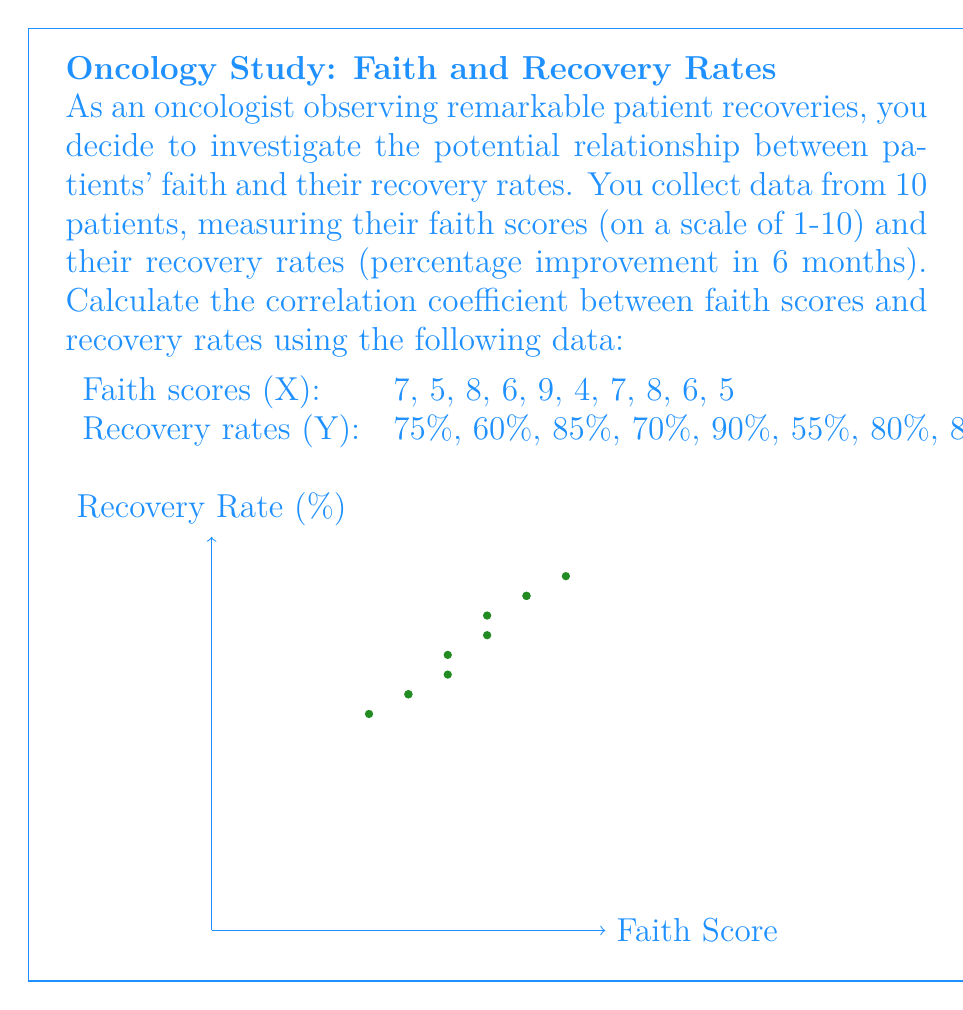Help me with this question. To calculate the correlation coefficient (r) between faith scores (X) and recovery rates (Y), we'll use the formula:

$$ r = \frac{n\sum xy - \sum x \sum y}{\sqrt{[n\sum x^2 - (\sum x)^2][n\sum y^2 - (\sum y)^2]}} $$

Step 1: Calculate the necessary sums:
$\sum x = 65$
$\sum y = 725$
$\sum xy = 4975$
$\sum x^2 = 449$
$\sum y^2 = 53875$
$n = 10$

Step 2: Substitute these values into the formula:

$$ r = \frac{10(4975) - (65)(725)}{\sqrt{[10(449) - 65^2][10(53875) - 725^2]}} $$

Step 3: Simplify:

$$ r = \frac{49750 - 47125}{\sqrt{(4490 - 4225)(538750 - 525625)}} $$

$$ r = \frac{2625}{\sqrt{265 * 13125}} $$

$$ r = \frac{2625}{\sqrt{3478125}} $$

$$ r = \frac{2625}{1865.51} $$

Step 4: Calculate the final result:

$$ r \approx 0.9085 $$
Answer: $0.9085$ 